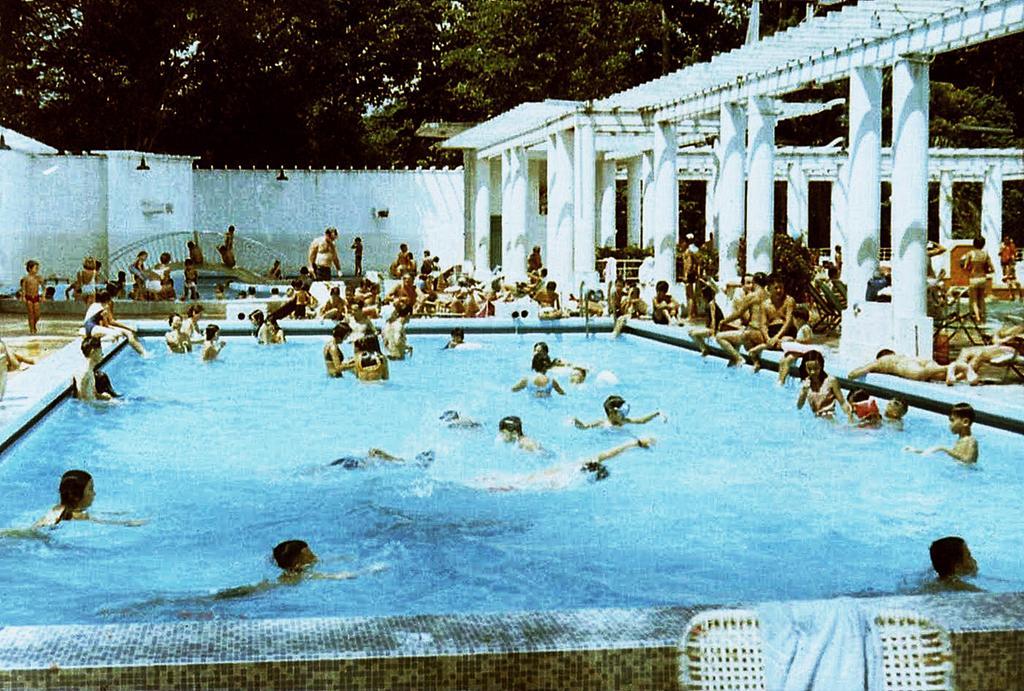Can you describe this image briefly? In this picture we can see a swimming pool in the front, there are some people in the water, we can see some people are sitting and some people are standing, on the right side there are pillars, we can see trees and a wall in the background, there is a chair and a cloth at the bottom. 